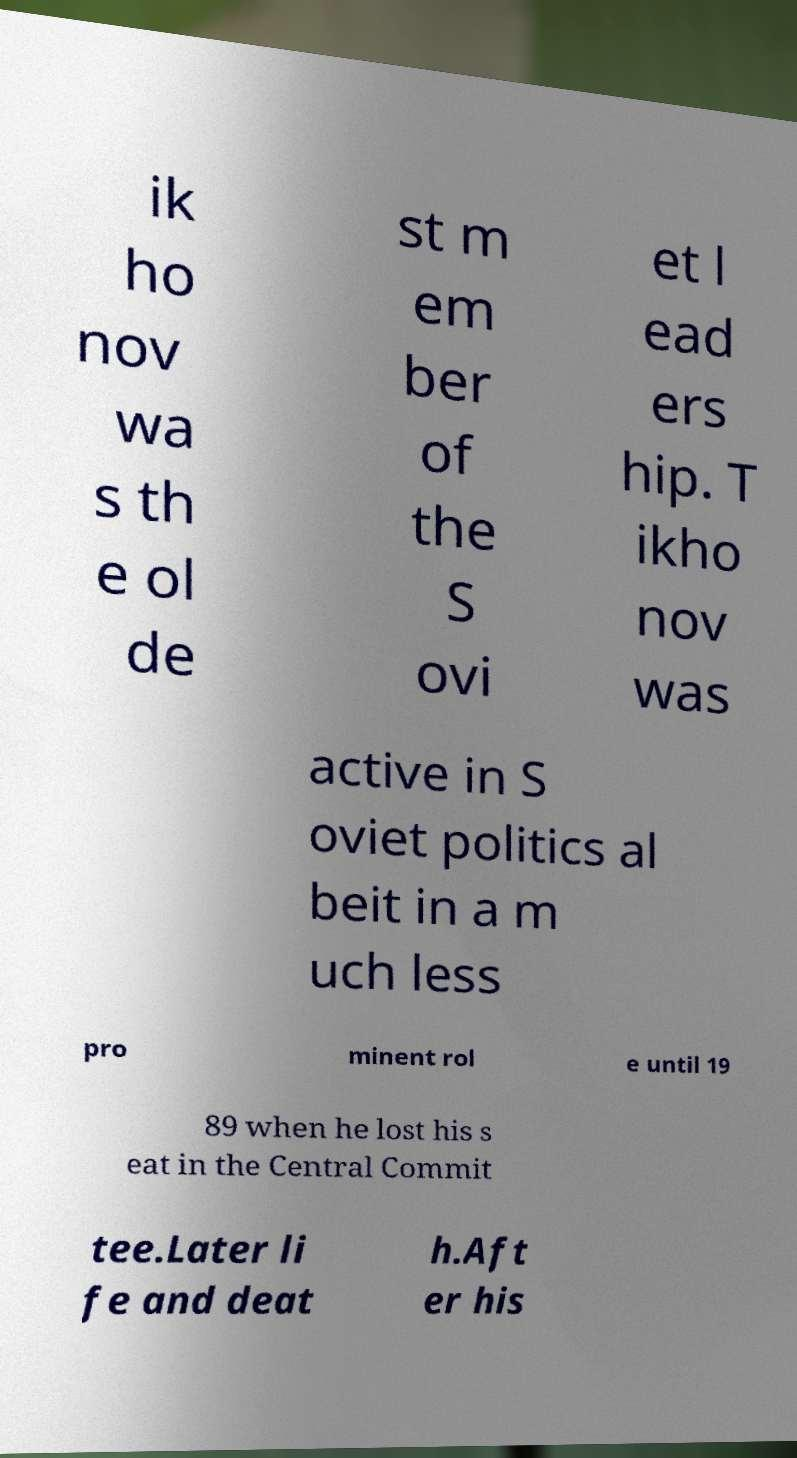Please read and relay the text visible in this image. What does it say? ik ho nov wa s th e ol de st m em ber of the S ovi et l ead ers hip. T ikho nov was active in S oviet politics al beit in a m uch less pro minent rol e until 19 89 when he lost his s eat in the Central Commit tee.Later li fe and deat h.Aft er his 